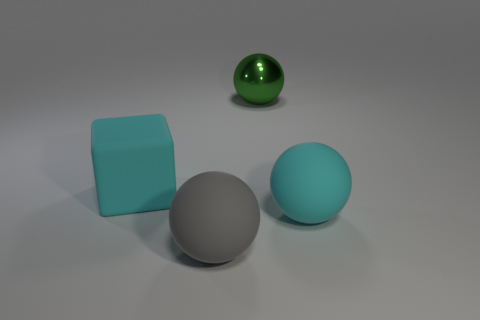There is a gray matte object that is the same size as the cyan block; what shape is it?
Provide a short and direct response. Sphere. Are there any other large green shiny objects of the same shape as the big green metallic object?
Provide a succinct answer. No. There is a object right of the green metallic object; is it the same color as the rubber object on the left side of the large gray rubber sphere?
Keep it short and to the point. Yes. Are there any objects in front of the large cyan rubber ball?
Offer a very short reply. Yes. What is the material of the big object that is both behind the big cyan sphere and to the right of the cyan block?
Your answer should be compact. Metal. Is the cyan thing to the right of the block made of the same material as the cube?
Offer a terse response. Yes. What is the big green ball made of?
Your answer should be very brief. Metal. Are there any other things that have the same color as the block?
Ensure brevity in your answer.  Yes. Are there any large cubes that are behind the cyan matte thing that is in front of the large cyan object to the left of the big green thing?
Make the answer very short. Yes. Do the big rubber ball right of the large green shiny sphere and the big block have the same color?
Ensure brevity in your answer.  Yes. 